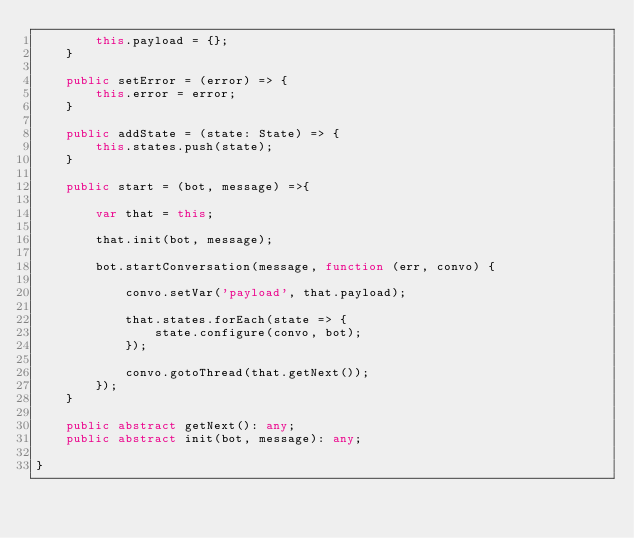<code> <loc_0><loc_0><loc_500><loc_500><_TypeScript_>        this.payload = {};
    }

    public setError = (error) => {
        this.error = error;
    }

    public addState = (state: State) => {
        this.states.push(state);
    }

    public start = (bot, message) =>{

        var that = this;

        that.init(bot, message);

        bot.startConversation(message, function (err, convo) {

            convo.setVar('payload', that.payload);
    
            that.states.forEach(state => {
                state.configure(convo, bot);
            });
    
            convo.gotoThread(that.getNext());
        });
    }

    public abstract getNext(): any;
    public abstract init(bot, message): any;

}</code> 